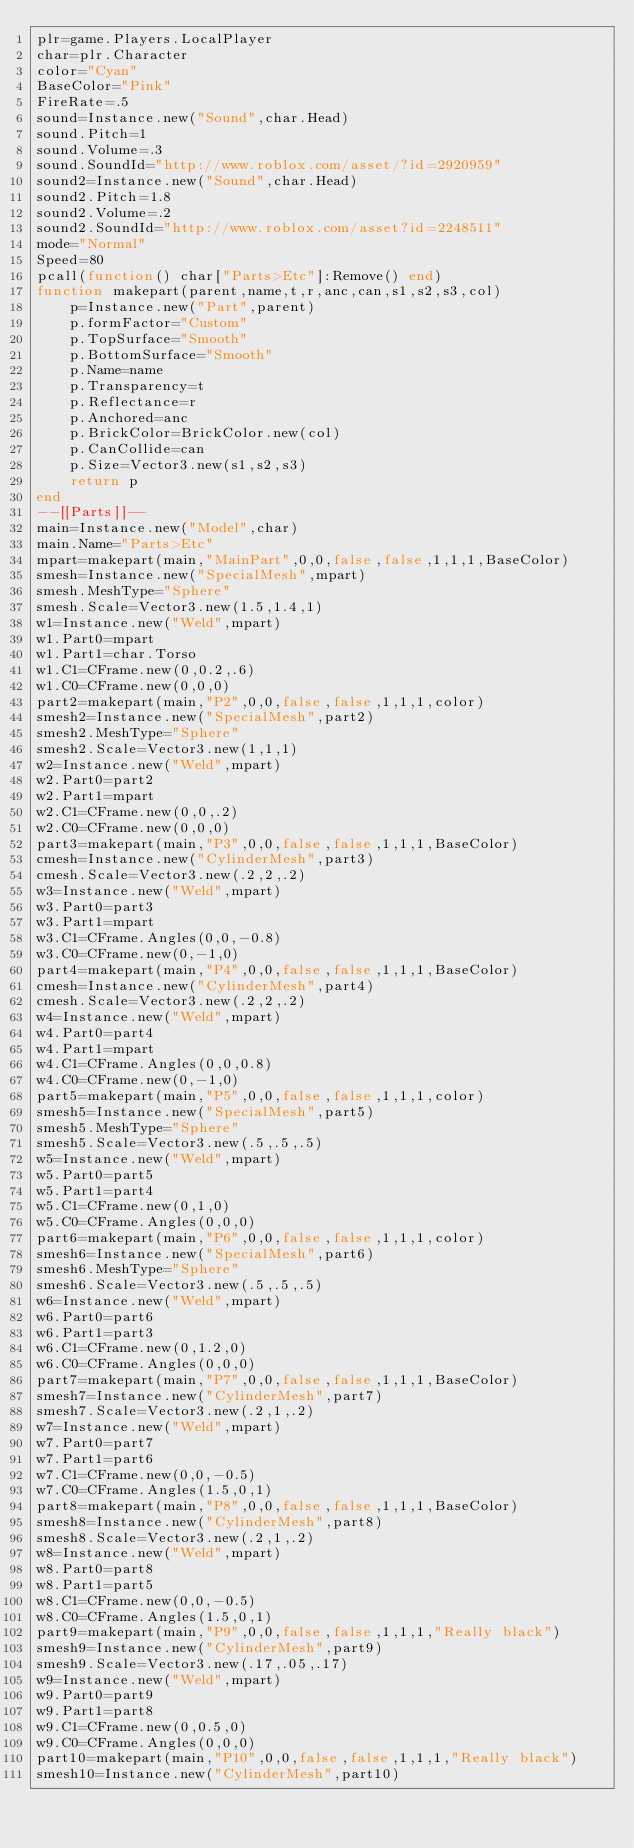Convert code to text. <code><loc_0><loc_0><loc_500><loc_500><_Lua_>plr=game.Players.LocalPlayer
char=plr.Character
color="Cyan"
BaseColor="Pink"
FireRate=.5
sound=Instance.new("Sound",char.Head)
sound.Pitch=1
sound.Volume=.3
sound.SoundId="http://www.roblox.com/asset/?id=2920959"
sound2=Instance.new("Sound",char.Head)
sound2.Pitch=1.8
sound2.Volume=.2
sound2.SoundId="http://www.roblox.com/asset?id=2248511"
mode="Normal"
Speed=80
pcall(function() char["Parts>Etc"]:Remove() end)
function makepart(parent,name,t,r,anc,can,s1,s2,s3,col)
    p=Instance.new("Part",parent)
    p.formFactor="Custom"
    p.TopSurface="Smooth"
    p.BottomSurface="Smooth"
    p.Name=name
    p.Transparency=t
    p.Reflectance=r
    p.Anchored=anc
    p.BrickColor=BrickColor.new(col)
    p.CanCollide=can
    p.Size=Vector3.new(s1,s2,s3)
    return p
end
--[[Parts]]--
main=Instance.new("Model",char)
main.Name="Parts>Etc"
mpart=makepart(main,"MainPart",0,0,false,false,1,1,1,BaseColor)
smesh=Instance.new("SpecialMesh",mpart)
smesh.MeshType="Sphere"
smesh.Scale=Vector3.new(1.5,1.4,1)
w1=Instance.new("Weld",mpart)
w1.Part0=mpart
w1.Part1=char.Torso
w1.C1=CFrame.new(0,0.2,.6)
w1.C0=CFrame.new(0,0,0)
part2=makepart(main,"P2",0,0,false,false,1,1,1,color)
smesh2=Instance.new("SpecialMesh",part2)
smesh2.MeshType="Sphere"
smesh2.Scale=Vector3.new(1,1,1)
w2=Instance.new("Weld",mpart)
w2.Part0=part2
w2.Part1=mpart
w2.C1=CFrame.new(0,0,.2)
w2.C0=CFrame.new(0,0,0)
part3=makepart(main,"P3",0,0,false,false,1,1,1,BaseColor)
cmesh=Instance.new("CylinderMesh",part3)
cmesh.Scale=Vector3.new(.2,2,.2)
w3=Instance.new("Weld",mpart)
w3.Part0=part3
w3.Part1=mpart
w3.C1=CFrame.Angles(0,0,-0.8)
w3.C0=CFrame.new(0,-1,0)
part4=makepart(main,"P4",0,0,false,false,1,1,1,BaseColor)
cmesh=Instance.new("CylinderMesh",part4)
cmesh.Scale=Vector3.new(.2,2,.2)
w4=Instance.new("Weld",mpart)
w4.Part0=part4
w4.Part1=mpart
w4.C1=CFrame.Angles(0,0,0.8)
w4.C0=CFrame.new(0,-1,0)
part5=makepart(main,"P5",0,0,false,false,1,1,1,color)
smesh5=Instance.new("SpecialMesh",part5)
smesh5.MeshType="Sphere"
smesh5.Scale=Vector3.new(.5,.5,.5)
w5=Instance.new("Weld",mpart)
w5.Part0=part5
w5.Part1=part4
w5.C1=CFrame.new(0,1,0)
w5.C0=CFrame.Angles(0,0,0)
part6=makepart(main,"P6",0,0,false,false,1,1,1,color)
smesh6=Instance.new("SpecialMesh",part6)
smesh6.MeshType="Sphere"
smesh6.Scale=Vector3.new(.5,.5,.5)
w6=Instance.new("Weld",mpart)
w6.Part0=part6
w6.Part1=part3
w6.C1=CFrame.new(0,1.2,0)
w6.C0=CFrame.Angles(0,0,0)
part7=makepart(main,"P7",0,0,false,false,1,1,1,BaseColor)
smesh7=Instance.new("CylinderMesh",part7)
smesh7.Scale=Vector3.new(.2,1,.2)
w7=Instance.new("Weld",mpart)
w7.Part0=part7
w7.Part1=part6
w7.C1=CFrame.new(0,0,-0.5)
w7.C0=CFrame.Angles(1.5,0,1)
part8=makepart(main,"P8",0,0,false,false,1,1,1,BaseColor)
smesh8=Instance.new("CylinderMesh",part8)
smesh8.Scale=Vector3.new(.2,1,.2)
w8=Instance.new("Weld",mpart)
w8.Part0=part8
w8.Part1=part5
w8.C1=CFrame.new(0,0,-0.5)
w8.C0=CFrame.Angles(1.5,0,1)
part9=makepart(main,"P9",0,0,false,false,1,1,1,"Really black")
smesh9=Instance.new("CylinderMesh",part9)
smesh9.Scale=Vector3.new(.17,.05,.17)
w9=Instance.new("Weld",mpart)
w9.Part0=part9
w9.Part1=part8
w9.C1=CFrame.new(0,0.5,0)
w9.C0=CFrame.Angles(0,0,0)
part10=makepart(main,"P10",0,0,false,false,1,1,1,"Really black")
smesh10=Instance.new("CylinderMesh",part10)</code> 